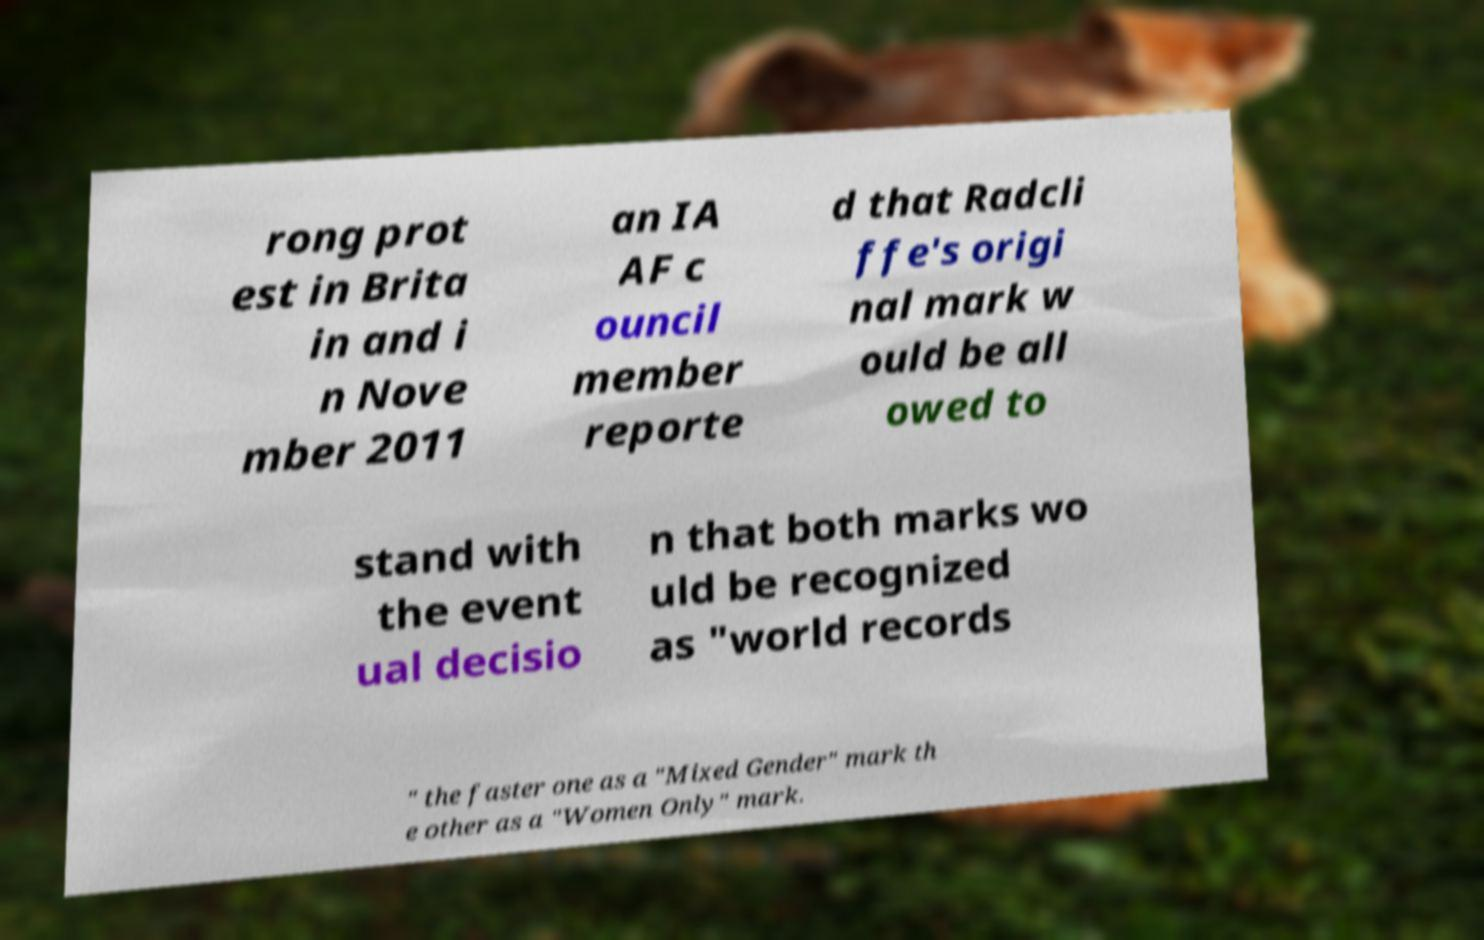Please read and relay the text visible in this image. What does it say? rong prot est in Brita in and i n Nove mber 2011 an IA AF c ouncil member reporte d that Radcli ffe's origi nal mark w ould be all owed to stand with the event ual decisio n that both marks wo uld be recognized as "world records " the faster one as a "Mixed Gender" mark th e other as a "Women Only" mark. 